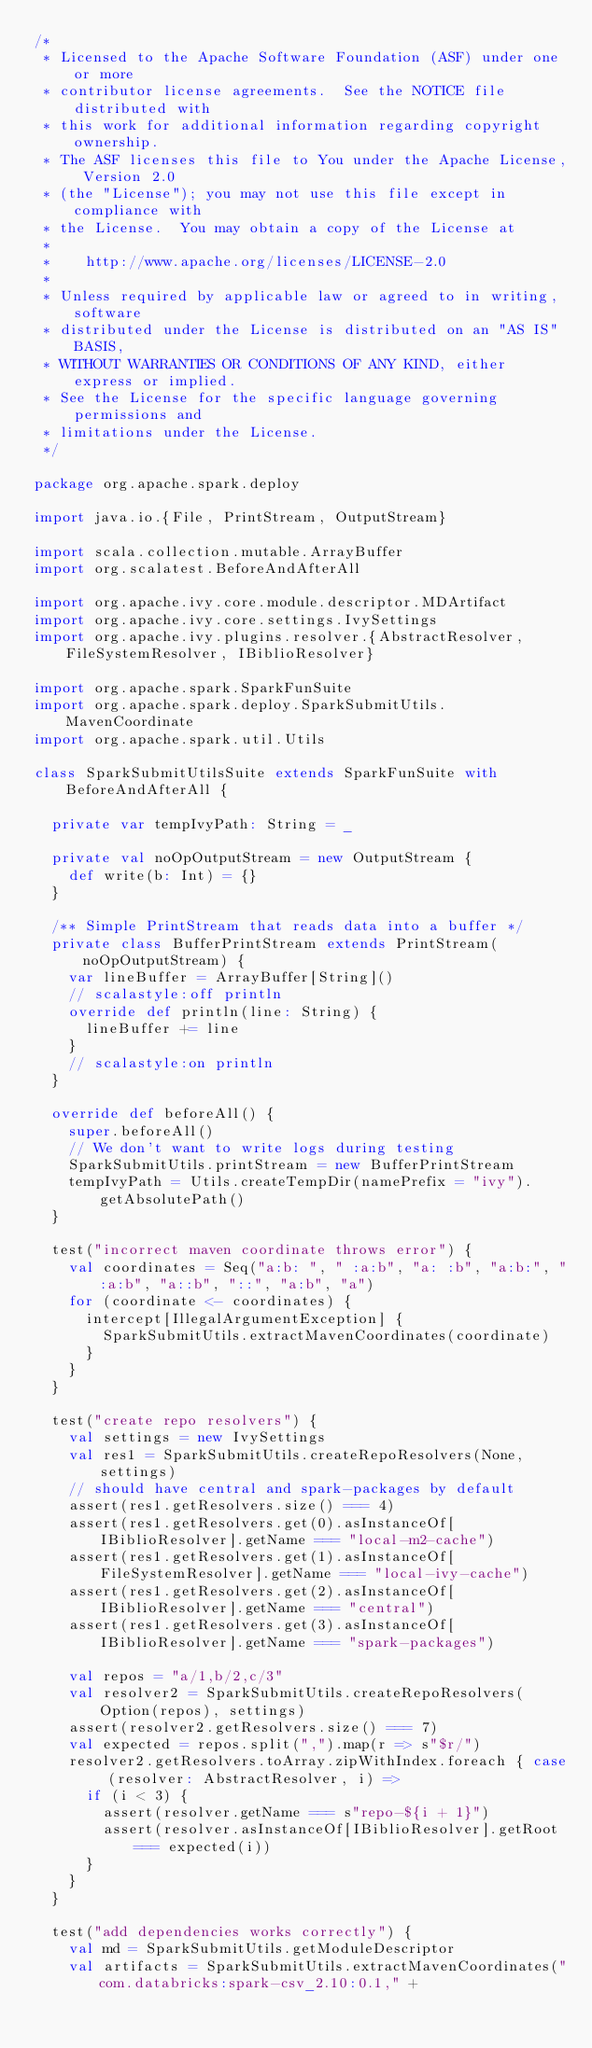<code> <loc_0><loc_0><loc_500><loc_500><_Scala_>/*
 * Licensed to the Apache Software Foundation (ASF) under one or more
 * contributor license agreements.  See the NOTICE file distributed with
 * this work for additional information regarding copyright ownership.
 * The ASF licenses this file to You under the Apache License, Version 2.0
 * (the "License"); you may not use this file except in compliance with
 * the License.  You may obtain a copy of the License at
 *
 *    http://www.apache.org/licenses/LICENSE-2.0
 *
 * Unless required by applicable law or agreed to in writing, software
 * distributed under the License is distributed on an "AS IS" BASIS,
 * WITHOUT WARRANTIES OR CONDITIONS OF ANY KIND, either express or implied.
 * See the License for the specific language governing permissions and
 * limitations under the License.
 */

package org.apache.spark.deploy

import java.io.{File, PrintStream, OutputStream}

import scala.collection.mutable.ArrayBuffer
import org.scalatest.BeforeAndAfterAll

import org.apache.ivy.core.module.descriptor.MDArtifact
import org.apache.ivy.core.settings.IvySettings
import org.apache.ivy.plugins.resolver.{AbstractResolver, FileSystemResolver, IBiblioResolver}

import org.apache.spark.SparkFunSuite
import org.apache.spark.deploy.SparkSubmitUtils.MavenCoordinate
import org.apache.spark.util.Utils

class SparkSubmitUtilsSuite extends SparkFunSuite with BeforeAndAfterAll {

  private var tempIvyPath: String = _

  private val noOpOutputStream = new OutputStream {
    def write(b: Int) = {}
  }

  /** Simple PrintStream that reads data into a buffer */
  private class BufferPrintStream extends PrintStream(noOpOutputStream) {
    var lineBuffer = ArrayBuffer[String]()
    // scalastyle:off println
    override def println(line: String) {
      lineBuffer += line
    }
    // scalastyle:on println
  }

  override def beforeAll() {
    super.beforeAll()
    // We don't want to write logs during testing
    SparkSubmitUtils.printStream = new BufferPrintStream
    tempIvyPath = Utils.createTempDir(namePrefix = "ivy").getAbsolutePath()
  }

  test("incorrect maven coordinate throws error") {
    val coordinates = Seq("a:b: ", " :a:b", "a: :b", "a:b:", ":a:b", "a::b", "::", "a:b", "a")
    for (coordinate <- coordinates) {
      intercept[IllegalArgumentException] {
        SparkSubmitUtils.extractMavenCoordinates(coordinate)
      }
    }
  }

  test("create repo resolvers") {
    val settings = new IvySettings
    val res1 = SparkSubmitUtils.createRepoResolvers(None, settings)
    // should have central and spark-packages by default
    assert(res1.getResolvers.size() === 4)
    assert(res1.getResolvers.get(0).asInstanceOf[IBiblioResolver].getName === "local-m2-cache")
    assert(res1.getResolvers.get(1).asInstanceOf[FileSystemResolver].getName === "local-ivy-cache")
    assert(res1.getResolvers.get(2).asInstanceOf[IBiblioResolver].getName === "central")
    assert(res1.getResolvers.get(3).asInstanceOf[IBiblioResolver].getName === "spark-packages")

    val repos = "a/1,b/2,c/3"
    val resolver2 = SparkSubmitUtils.createRepoResolvers(Option(repos), settings)
    assert(resolver2.getResolvers.size() === 7)
    val expected = repos.split(",").map(r => s"$r/")
    resolver2.getResolvers.toArray.zipWithIndex.foreach { case (resolver: AbstractResolver, i) =>
      if (i < 3) {
        assert(resolver.getName === s"repo-${i + 1}")
        assert(resolver.asInstanceOf[IBiblioResolver].getRoot === expected(i))
      }
    }
  }

  test("add dependencies works correctly") {
    val md = SparkSubmitUtils.getModuleDescriptor
    val artifacts = SparkSubmitUtils.extractMavenCoordinates("com.databricks:spark-csv_2.10:0.1," +</code> 